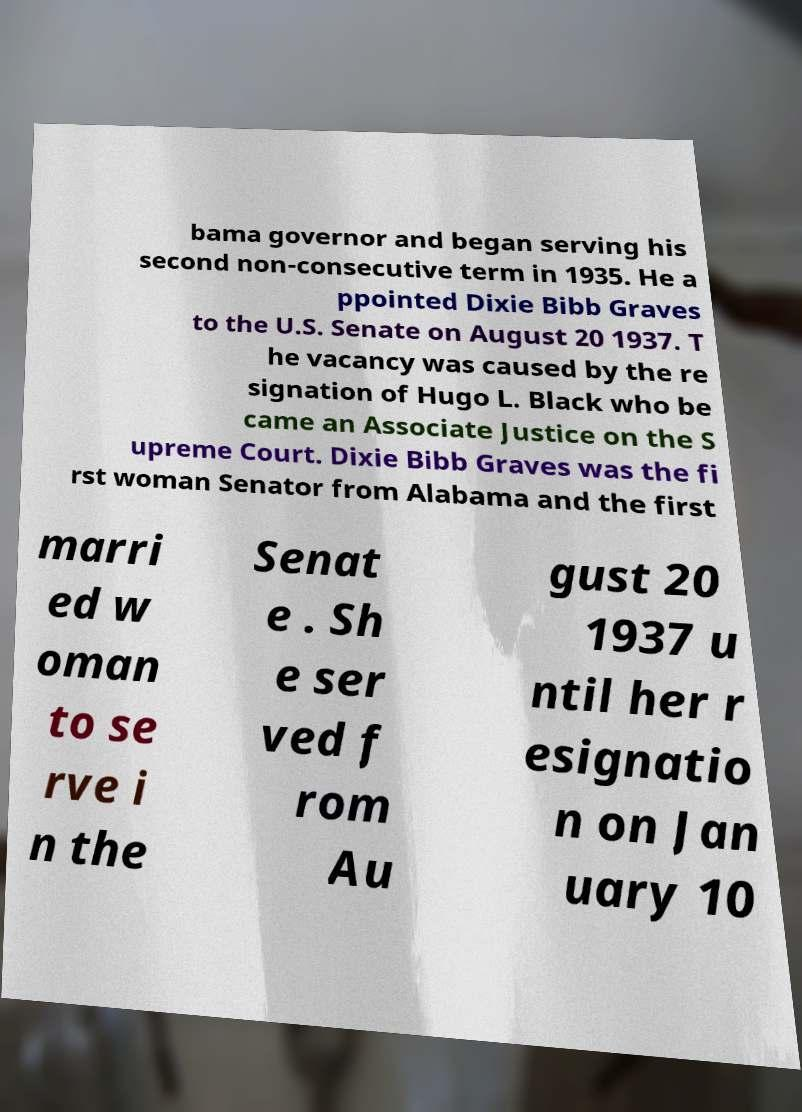I need the written content from this picture converted into text. Can you do that? bama governor and began serving his second non-consecutive term in 1935. He a ppointed Dixie Bibb Graves to the U.S. Senate on August 20 1937. T he vacancy was caused by the re signation of Hugo L. Black who be came an Associate Justice on the S upreme Court. Dixie Bibb Graves was the fi rst woman Senator from Alabama and the first marri ed w oman to se rve i n the Senat e . Sh e ser ved f rom Au gust 20 1937 u ntil her r esignatio n on Jan uary 10 